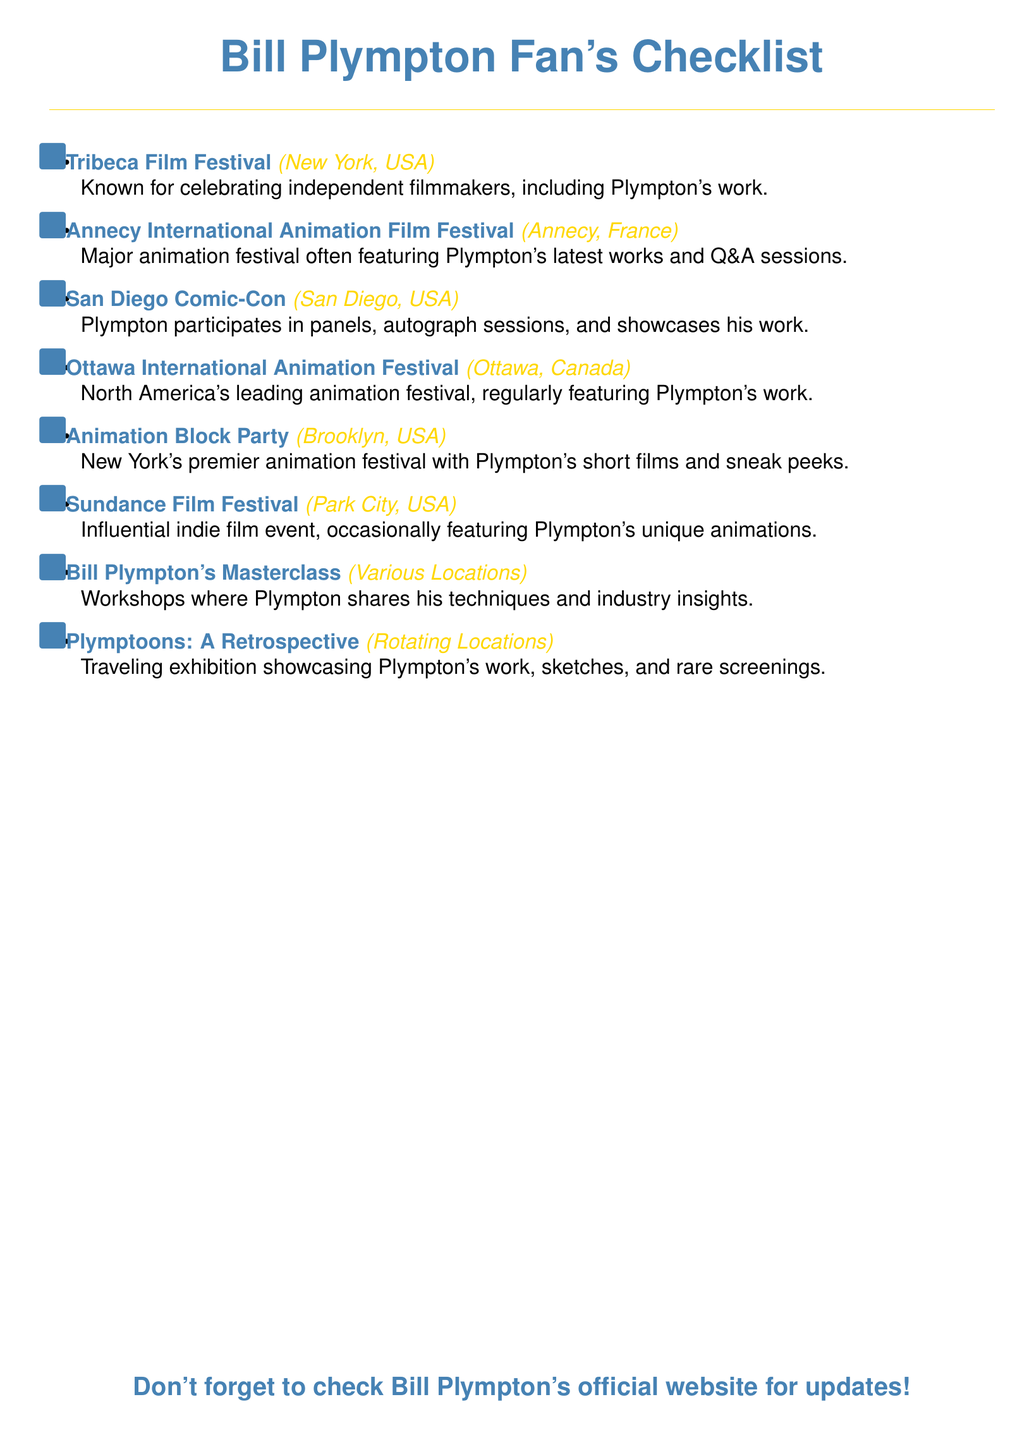what is the first event listed? The first event on the checklist is the one mentioned at the beginning of the item list.
Answer: Tribeca Film Festival how many workshops does Bill Plympton conduct? The checklist includes a specific section dedicated to Plympton's workshops, stating that they occur at various locations.
Answer: Masterclass which event is located in Annecy, France? The document explicitly names the event that takes place in Annecy, France.
Answer: Annecy International Animation Film Festival what type of festival is the Animation Block Party? The checklist describes this event type in the context of its location and focus.
Answer: Animation festival how many events are listed in total? The total number of events can be derived by counting each item in the checklist.
Answer: Eight which festival is known for celebrating independent filmmakers? This information is included in the description for the event that takes place in New York.
Answer: Tribeca Film Festival where does Plymptoons: A Retrospective occur? The checklist mentions that this exhibition is hosted in rotating locations.
Answer: Rotating Locations what is the event in San Diego, USA? The checklist provides the name of the specific event that occurs in San Diego.
Answer: San Diego Comic-Con 